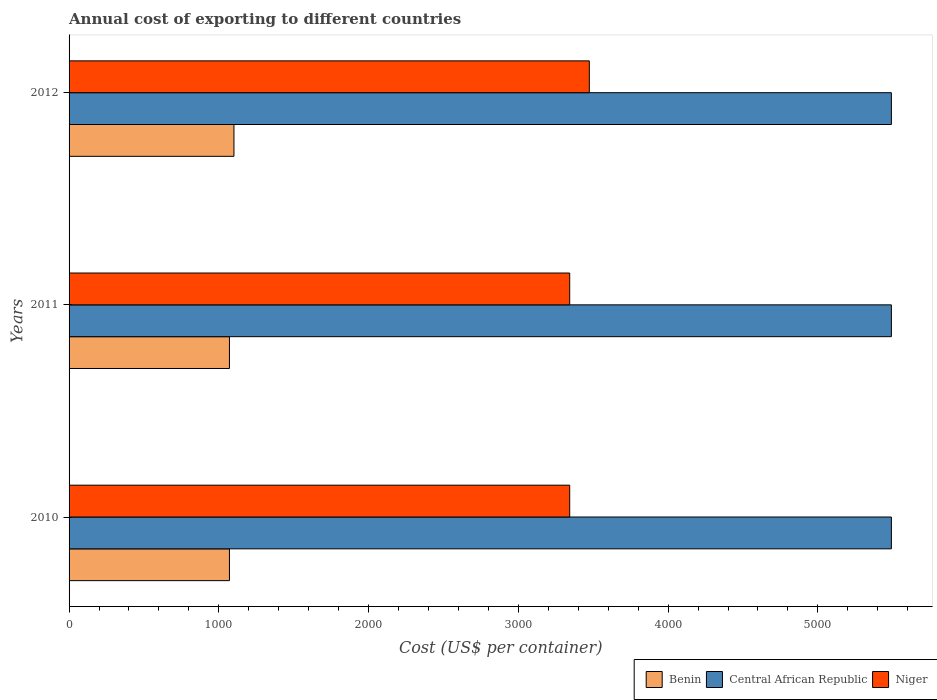How many different coloured bars are there?
Ensure brevity in your answer.  3. Are the number of bars on each tick of the Y-axis equal?
Give a very brief answer. Yes. How many bars are there on the 3rd tick from the top?
Offer a terse response. 3. How many bars are there on the 3rd tick from the bottom?
Ensure brevity in your answer.  3. What is the total annual cost of exporting in Benin in 2011?
Provide a succinct answer. 1071. Across all years, what is the maximum total annual cost of exporting in Benin?
Offer a terse response. 1101. Across all years, what is the minimum total annual cost of exporting in Benin?
Give a very brief answer. 1071. In which year was the total annual cost of exporting in Niger maximum?
Your answer should be compact. 2012. What is the total total annual cost of exporting in Benin in the graph?
Offer a terse response. 3243. What is the difference between the total annual cost of exporting in Benin in 2010 and that in 2011?
Offer a terse response. 0. What is the difference between the total annual cost of exporting in Central African Republic in 2010 and the total annual cost of exporting in Niger in 2012?
Offer a very short reply. 2017. What is the average total annual cost of exporting in Central African Republic per year?
Keep it short and to the point. 5491. In the year 2010, what is the difference between the total annual cost of exporting in Central African Republic and total annual cost of exporting in Niger?
Your answer should be very brief. 2148. In how many years, is the total annual cost of exporting in Benin greater than 1000 US$?
Give a very brief answer. 3. What is the ratio of the total annual cost of exporting in Niger in 2010 to that in 2012?
Provide a short and direct response. 0.96. Is the difference between the total annual cost of exporting in Central African Republic in 2011 and 2012 greater than the difference between the total annual cost of exporting in Niger in 2011 and 2012?
Provide a succinct answer. Yes. What is the difference between the highest and the lowest total annual cost of exporting in Benin?
Your answer should be very brief. 30. Is the sum of the total annual cost of exporting in Central African Republic in 2010 and 2012 greater than the maximum total annual cost of exporting in Niger across all years?
Make the answer very short. Yes. What does the 1st bar from the top in 2010 represents?
Your answer should be compact. Niger. What does the 1st bar from the bottom in 2012 represents?
Offer a very short reply. Benin. How many bars are there?
Your answer should be very brief. 9. Are all the bars in the graph horizontal?
Offer a very short reply. Yes. Are the values on the major ticks of X-axis written in scientific E-notation?
Provide a short and direct response. No. Does the graph contain grids?
Provide a succinct answer. No. How are the legend labels stacked?
Your response must be concise. Horizontal. What is the title of the graph?
Your answer should be very brief. Annual cost of exporting to different countries. What is the label or title of the X-axis?
Your answer should be compact. Cost (US$ per container). What is the Cost (US$ per container) of Benin in 2010?
Give a very brief answer. 1071. What is the Cost (US$ per container) of Central African Republic in 2010?
Keep it short and to the point. 5491. What is the Cost (US$ per container) in Niger in 2010?
Provide a succinct answer. 3343. What is the Cost (US$ per container) of Benin in 2011?
Give a very brief answer. 1071. What is the Cost (US$ per container) in Central African Republic in 2011?
Make the answer very short. 5491. What is the Cost (US$ per container) in Niger in 2011?
Provide a succinct answer. 3343. What is the Cost (US$ per container) in Benin in 2012?
Give a very brief answer. 1101. What is the Cost (US$ per container) of Central African Republic in 2012?
Your response must be concise. 5491. What is the Cost (US$ per container) in Niger in 2012?
Your response must be concise. 3474. Across all years, what is the maximum Cost (US$ per container) in Benin?
Offer a terse response. 1101. Across all years, what is the maximum Cost (US$ per container) in Central African Republic?
Your response must be concise. 5491. Across all years, what is the maximum Cost (US$ per container) of Niger?
Give a very brief answer. 3474. Across all years, what is the minimum Cost (US$ per container) in Benin?
Keep it short and to the point. 1071. Across all years, what is the minimum Cost (US$ per container) in Central African Republic?
Provide a short and direct response. 5491. Across all years, what is the minimum Cost (US$ per container) of Niger?
Offer a terse response. 3343. What is the total Cost (US$ per container) of Benin in the graph?
Make the answer very short. 3243. What is the total Cost (US$ per container) of Central African Republic in the graph?
Provide a short and direct response. 1.65e+04. What is the total Cost (US$ per container) of Niger in the graph?
Make the answer very short. 1.02e+04. What is the difference between the Cost (US$ per container) in Niger in 2010 and that in 2012?
Ensure brevity in your answer.  -131. What is the difference between the Cost (US$ per container) in Central African Republic in 2011 and that in 2012?
Provide a succinct answer. 0. What is the difference between the Cost (US$ per container) of Niger in 2011 and that in 2012?
Provide a succinct answer. -131. What is the difference between the Cost (US$ per container) of Benin in 2010 and the Cost (US$ per container) of Central African Republic in 2011?
Give a very brief answer. -4420. What is the difference between the Cost (US$ per container) of Benin in 2010 and the Cost (US$ per container) of Niger in 2011?
Give a very brief answer. -2272. What is the difference between the Cost (US$ per container) in Central African Republic in 2010 and the Cost (US$ per container) in Niger in 2011?
Offer a terse response. 2148. What is the difference between the Cost (US$ per container) of Benin in 2010 and the Cost (US$ per container) of Central African Republic in 2012?
Provide a short and direct response. -4420. What is the difference between the Cost (US$ per container) in Benin in 2010 and the Cost (US$ per container) in Niger in 2012?
Offer a very short reply. -2403. What is the difference between the Cost (US$ per container) in Central African Republic in 2010 and the Cost (US$ per container) in Niger in 2012?
Offer a terse response. 2017. What is the difference between the Cost (US$ per container) in Benin in 2011 and the Cost (US$ per container) in Central African Republic in 2012?
Your answer should be compact. -4420. What is the difference between the Cost (US$ per container) in Benin in 2011 and the Cost (US$ per container) in Niger in 2012?
Ensure brevity in your answer.  -2403. What is the difference between the Cost (US$ per container) in Central African Republic in 2011 and the Cost (US$ per container) in Niger in 2012?
Ensure brevity in your answer.  2017. What is the average Cost (US$ per container) of Benin per year?
Provide a succinct answer. 1081. What is the average Cost (US$ per container) in Central African Republic per year?
Your response must be concise. 5491. What is the average Cost (US$ per container) in Niger per year?
Provide a succinct answer. 3386.67. In the year 2010, what is the difference between the Cost (US$ per container) of Benin and Cost (US$ per container) of Central African Republic?
Provide a short and direct response. -4420. In the year 2010, what is the difference between the Cost (US$ per container) of Benin and Cost (US$ per container) of Niger?
Ensure brevity in your answer.  -2272. In the year 2010, what is the difference between the Cost (US$ per container) in Central African Republic and Cost (US$ per container) in Niger?
Ensure brevity in your answer.  2148. In the year 2011, what is the difference between the Cost (US$ per container) in Benin and Cost (US$ per container) in Central African Republic?
Keep it short and to the point. -4420. In the year 2011, what is the difference between the Cost (US$ per container) in Benin and Cost (US$ per container) in Niger?
Keep it short and to the point. -2272. In the year 2011, what is the difference between the Cost (US$ per container) of Central African Republic and Cost (US$ per container) of Niger?
Your answer should be very brief. 2148. In the year 2012, what is the difference between the Cost (US$ per container) of Benin and Cost (US$ per container) of Central African Republic?
Offer a terse response. -4390. In the year 2012, what is the difference between the Cost (US$ per container) of Benin and Cost (US$ per container) of Niger?
Your response must be concise. -2373. In the year 2012, what is the difference between the Cost (US$ per container) in Central African Republic and Cost (US$ per container) in Niger?
Offer a very short reply. 2017. What is the ratio of the Cost (US$ per container) in Benin in 2010 to that in 2011?
Your answer should be very brief. 1. What is the ratio of the Cost (US$ per container) of Central African Republic in 2010 to that in 2011?
Give a very brief answer. 1. What is the ratio of the Cost (US$ per container) of Niger in 2010 to that in 2011?
Your answer should be compact. 1. What is the ratio of the Cost (US$ per container) in Benin in 2010 to that in 2012?
Give a very brief answer. 0.97. What is the ratio of the Cost (US$ per container) of Central African Republic in 2010 to that in 2012?
Provide a succinct answer. 1. What is the ratio of the Cost (US$ per container) in Niger in 2010 to that in 2012?
Give a very brief answer. 0.96. What is the ratio of the Cost (US$ per container) in Benin in 2011 to that in 2012?
Make the answer very short. 0.97. What is the ratio of the Cost (US$ per container) in Central African Republic in 2011 to that in 2012?
Your response must be concise. 1. What is the ratio of the Cost (US$ per container) of Niger in 2011 to that in 2012?
Give a very brief answer. 0.96. What is the difference between the highest and the second highest Cost (US$ per container) of Benin?
Your answer should be compact. 30. What is the difference between the highest and the second highest Cost (US$ per container) of Niger?
Your response must be concise. 131. What is the difference between the highest and the lowest Cost (US$ per container) in Niger?
Give a very brief answer. 131. 